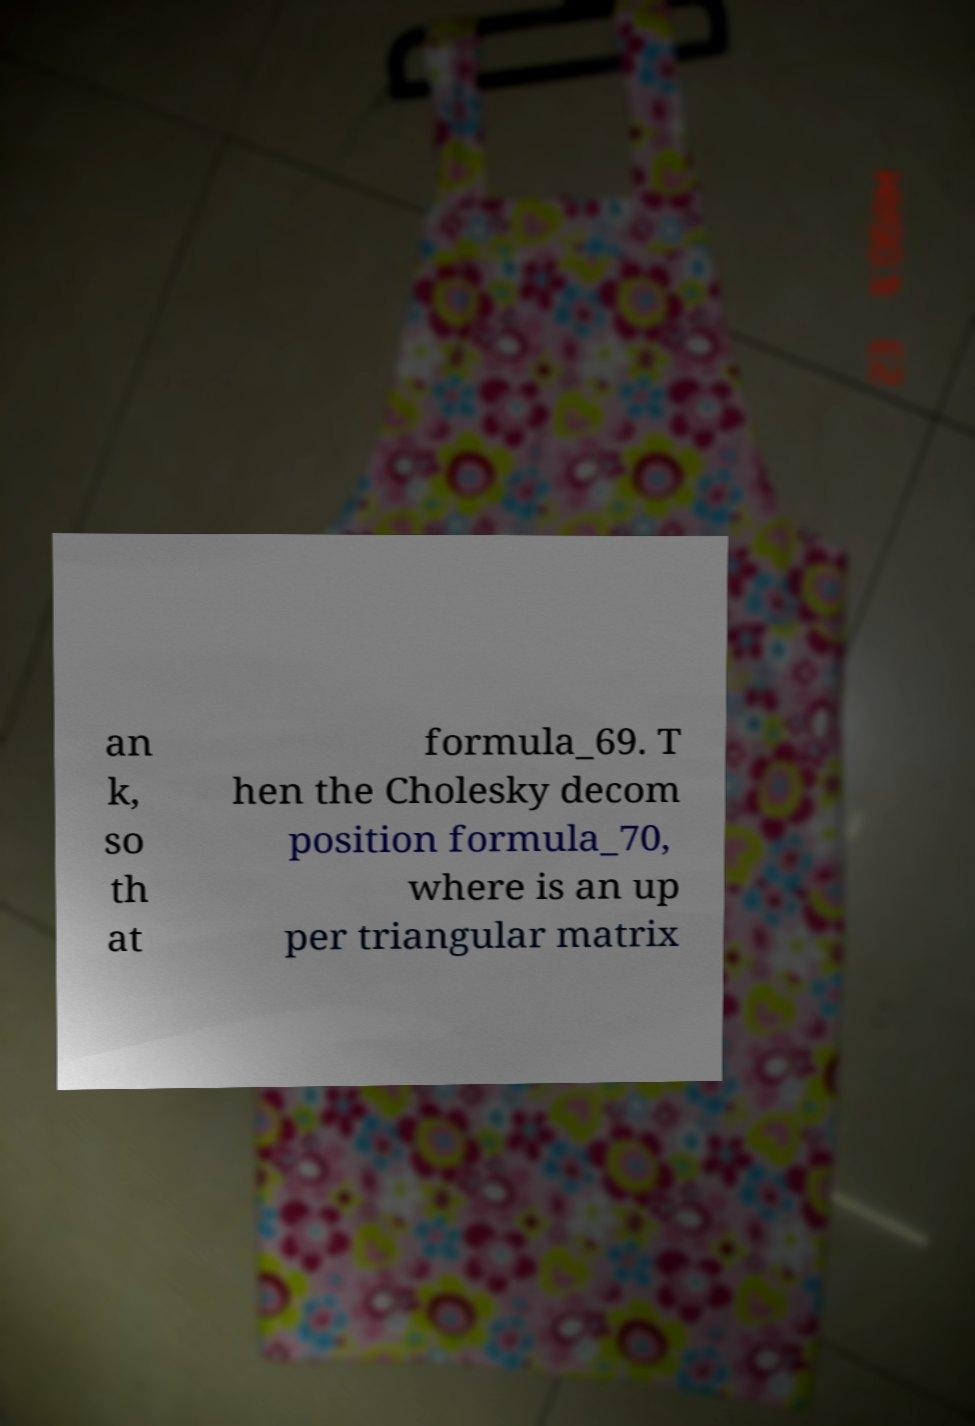Could you assist in decoding the text presented in this image and type it out clearly? an k, so th at formula_69. T hen the Cholesky decom position formula_70, where is an up per triangular matrix 